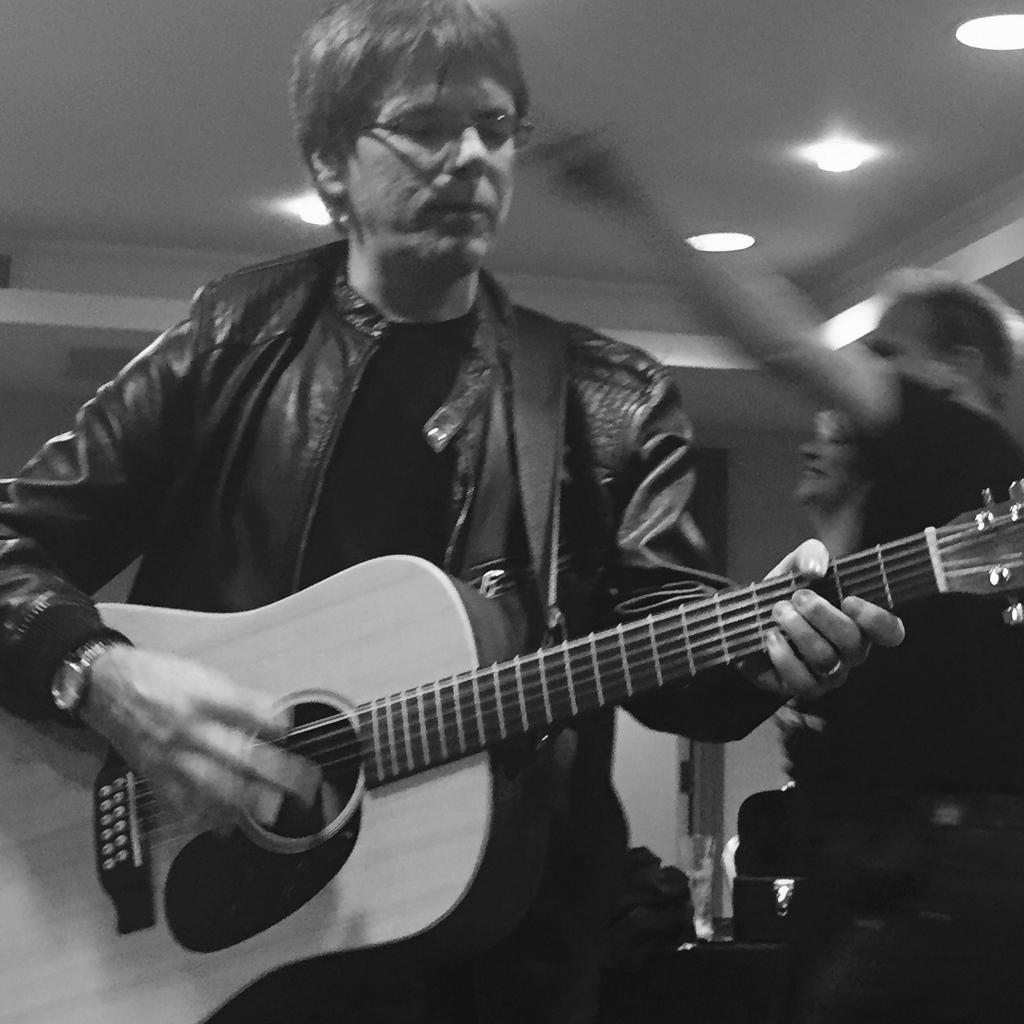In one or two sentences, can you explain what this image depicts? As we can see in the image there is a man holding guitar. 